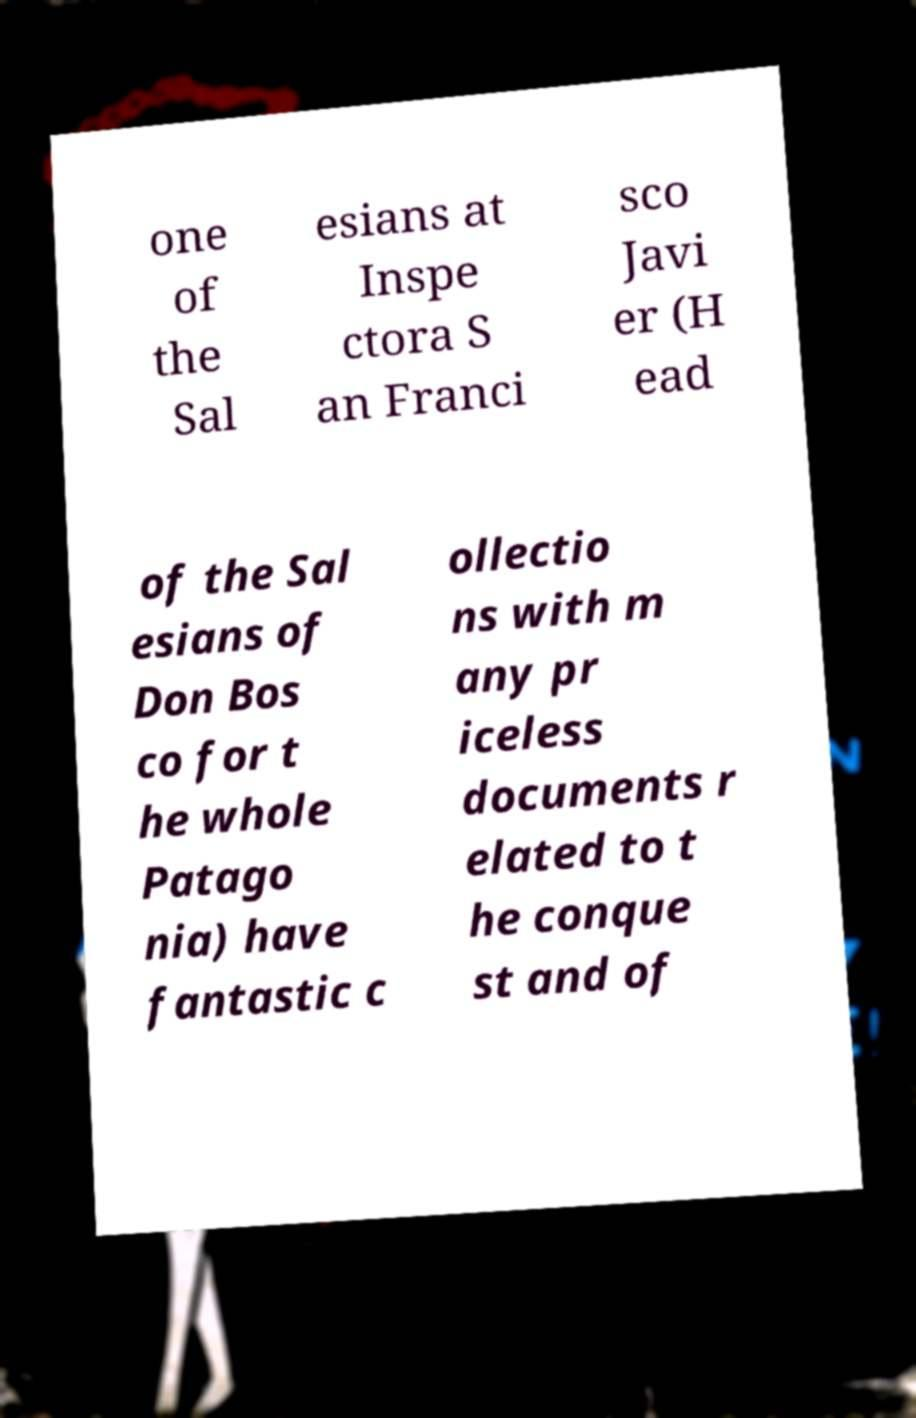Can you read and provide the text displayed in the image?This photo seems to have some interesting text. Can you extract and type it out for me? one of the Sal esians at Inspe ctora S an Franci sco Javi er (H ead of the Sal esians of Don Bos co for t he whole Patago nia) have fantastic c ollectio ns with m any pr iceless documents r elated to t he conque st and of 